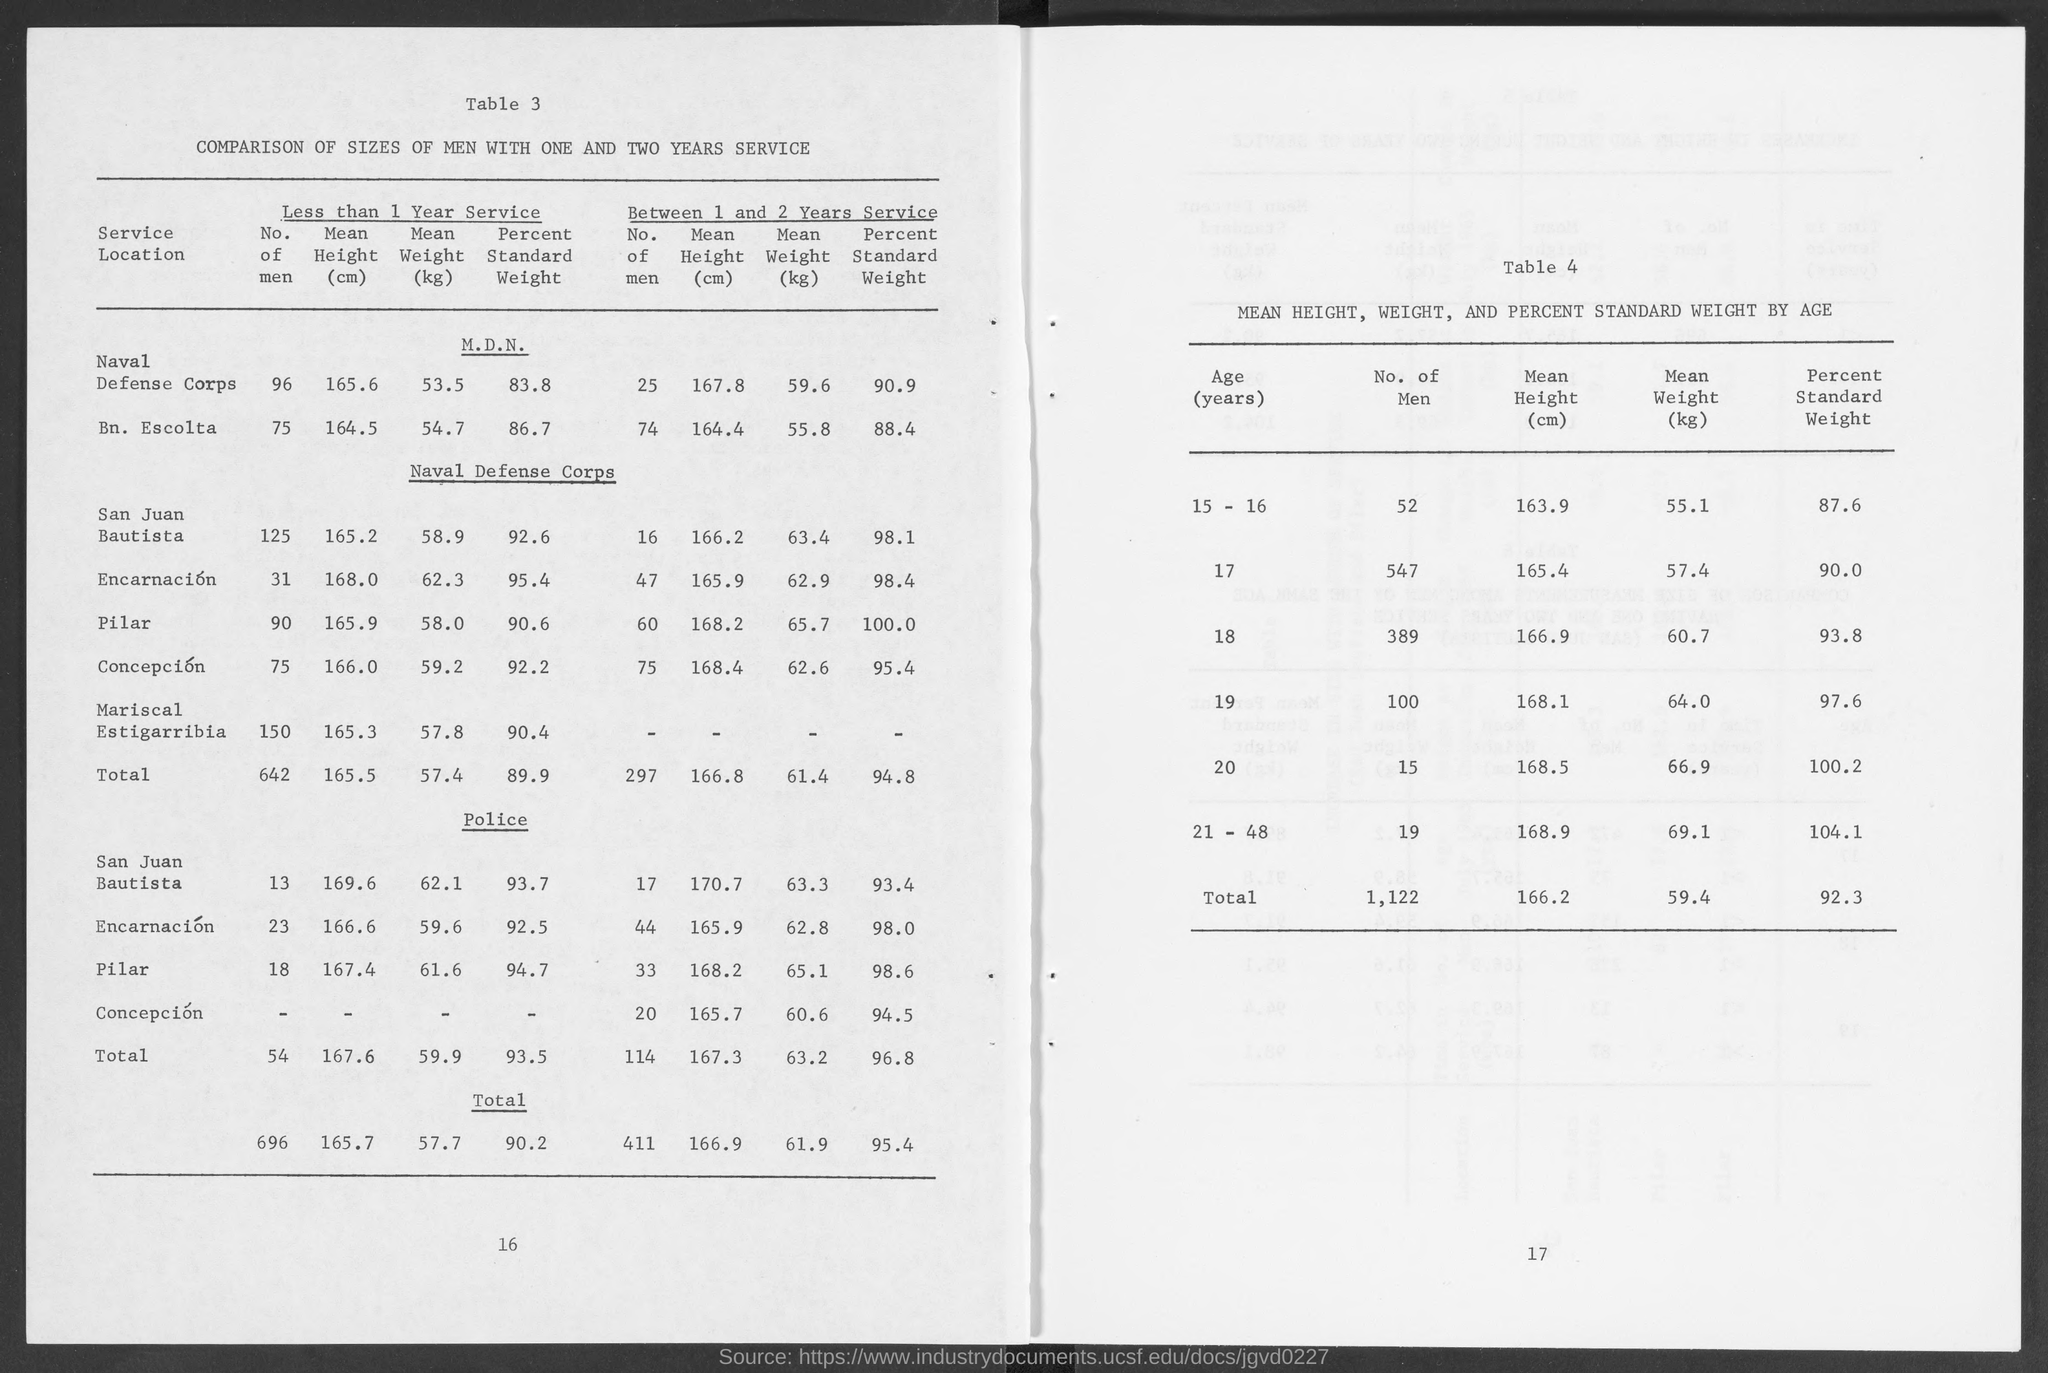Specify some key components in this picture. The table titled 'COMPARISON OF SIZES OF MEN WITH ONE AND TWO YEARS SERVICE.' presents a comparison of the sizes of men who have served for one and two years. The percent standard weight corresponding to the oldest age group is 104.1%. The title of table 4 is 'MEAN HEIGHT, WEIGHT, AND PERCENT STANDARD WEIGHT BY AGE.' The location with the highest mean height of persons with less than 1 year of service is San Juan Bautista. The age group with the highest number of men was 17 years old. 